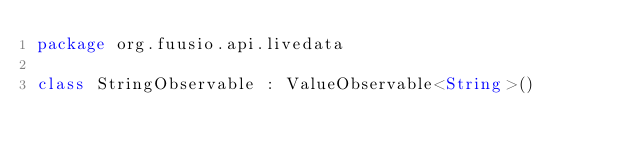Convert code to text. <code><loc_0><loc_0><loc_500><loc_500><_Kotlin_>package org.fuusio.api.livedata

class StringObservable : ValueObservable<String>()</code> 